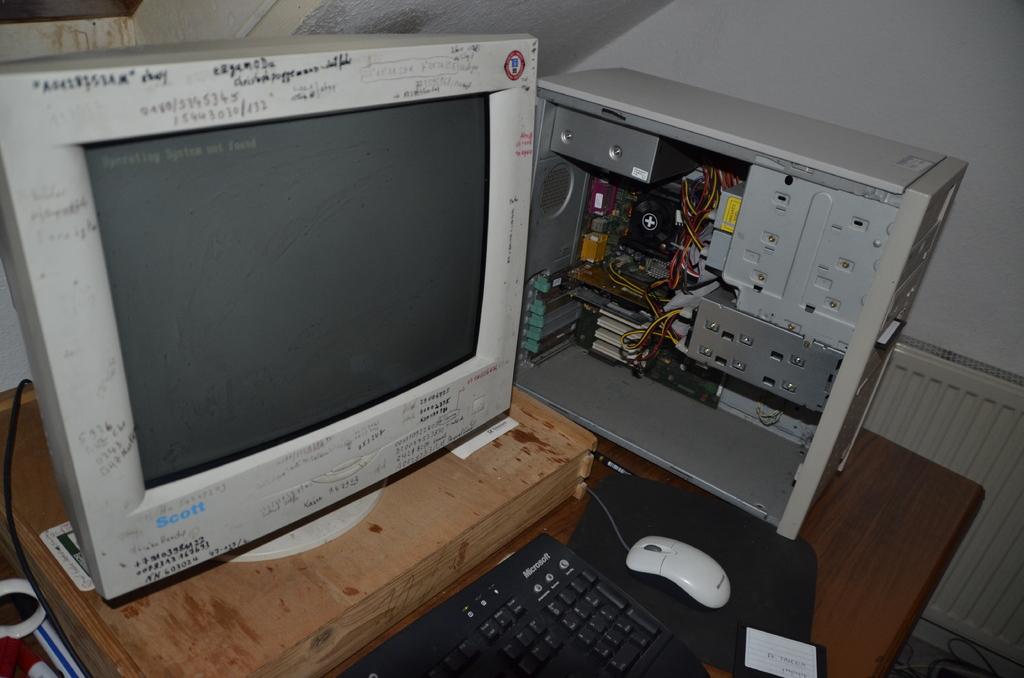Does that say scott on the monitor?
Your answer should be compact. Yes. What is one of the numbers written on the monitor?
Give a very brief answer. Unanswerable. 